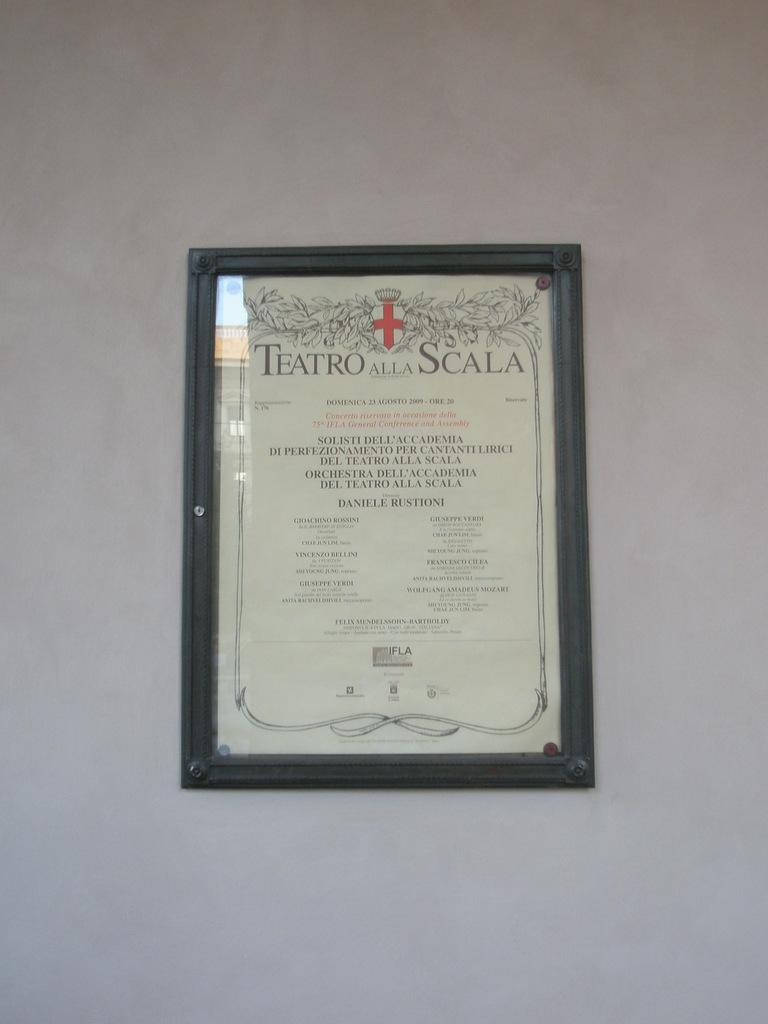<image>
Summarize the visual content of the image. a framed teatro alla scala sign and its hung on the wall 